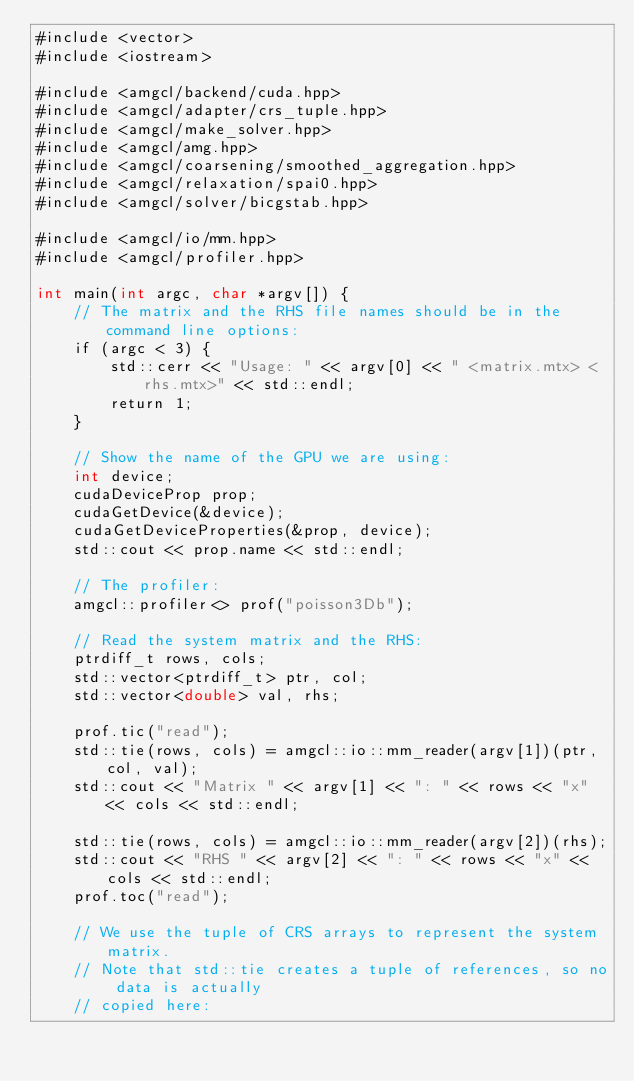<code> <loc_0><loc_0><loc_500><loc_500><_Cuda_>#include <vector>
#include <iostream>

#include <amgcl/backend/cuda.hpp>
#include <amgcl/adapter/crs_tuple.hpp>
#include <amgcl/make_solver.hpp>
#include <amgcl/amg.hpp>
#include <amgcl/coarsening/smoothed_aggregation.hpp>
#include <amgcl/relaxation/spai0.hpp>
#include <amgcl/solver/bicgstab.hpp>

#include <amgcl/io/mm.hpp>
#include <amgcl/profiler.hpp>

int main(int argc, char *argv[]) {
    // The matrix and the RHS file names should be in the command line options:
    if (argc < 3) {
        std::cerr << "Usage: " << argv[0] << " <matrix.mtx> <rhs.mtx>" << std::endl;
        return 1;
    }

    // Show the name of the GPU we are using:
    int device;
    cudaDeviceProp prop;
    cudaGetDevice(&device);
    cudaGetDeviceProperties(&prop, device);
    std::cout << prop.name << std::endl;

    // The profiler:
    amgcl::profiler<> prof("poisson3Db");

    // Read the system matrix and the RHS:
    ptrdiff_t rows, cols;
    std::vector<ptrdiff_t> ptr, col;
    std::vector<double> val, rhs;

    prof.tic("read");
    std::tie(rows, cols) = amgcl::io::mm_reader(argv[1])(ptr, col, val);
    std::cout << "Matrix " << argv[1] << ": " << rows << "x" << cols << std::endl;

    std::tie(rows, cols) = amgcl::io::mm_reader(argv[2])(rhs);
    std::cout << "RHS " << argv[2] << ": " << rows << "x" << cols << std::endl;
    prof.toc("read");

    // We use the tuple of CRS arrays to represent the system matrix.
    // Note that std::tie creates a tuple of references, so no data is actually
    // copied here:</code> 